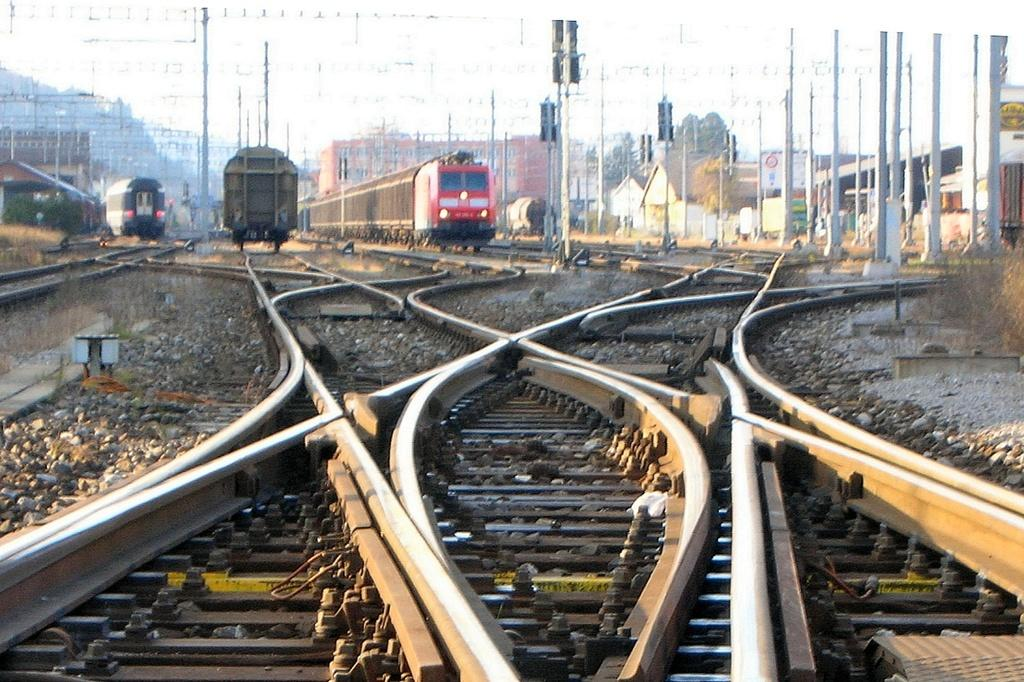What type of transportation infrastructure is visible in the image? There are train tracks in the image. What vehicles are present on the train tracks? There are trains in the image. What type of structures can be seen in the image? There are buildings in the image. What else can be seen in the image besides the train tracks, trains, and buildings? There are poles in the image. Where is the harbor located in the image? There is no harbor present in the image. What type of unit is being used to measure the distance between the poles in the image? The image does not provide any information about units of measurement for the distance between the poles. 